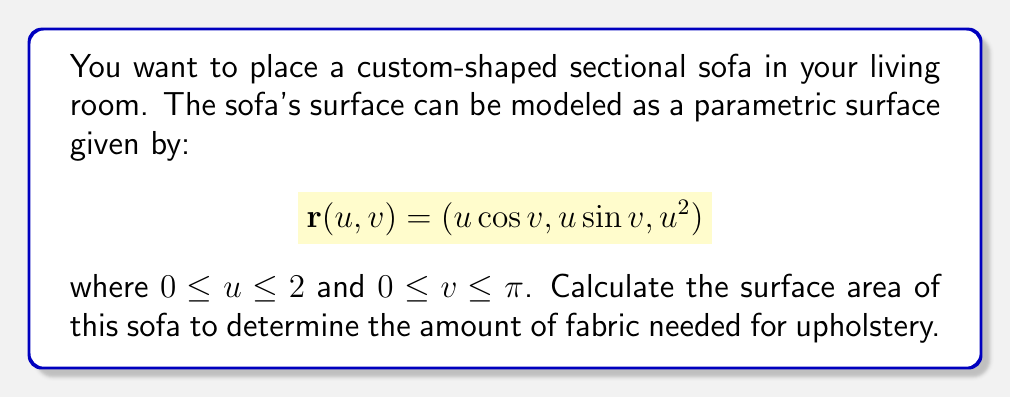Give your solution to this math problem. To calculate the surface area of a parametric surface, we use the surface integral formula:

$$A = \iint_S \sqrt{EG - F^2} \,du\,dv$$

where $E$, $F$, and $G$ are the coefficients of the first fundamental form.

Step 1: Calculate the partial derivatives
$$\frac{\partial \mathbf{r}}{\partial u} = (\cos v, \sin v, 2u)$$
$$\frac{\partial \mathbf{r}}{\partial v} = (-u\sin v, u\cos v, 0)$$

Step 2: Calculate $E$, $F$, and $G$
$$E = \left(\frac{\partial \mathbf{r}}{\partial u}\right)^2 = \cos^2 v + \sin^2 v + 4u^2 = 1 + 4u^2$$
$$F = \frac{\partial \mathbf{r}}{\partial u} \cdot \frac{\partial \mathbf{r}}{\partial v} = -u\sin v \cos v + u\sin v \cos v = 0$$
$$G = \left(\frac{\partial \mathbf{r}}{\partial v}\right)^2 = u^2\sin^2 v + u^2\cos^2 v = u^2$$

Step 3: Calculate $EG - F^2$
$$EG - F^2 = (1 + 4u^2)(u^2) - 0^2 = u^2 + 4u^4$$

Step 4: Set up the surface integral
$$A = \int_0^\pi \int_0^2 \sqrt{u^2 + 4u^4} \,du\,dv$$

Step 5: Evaluate the integral
First, integrate with respect to $u$:
$$\int_0^2 \sqrt{u^2 + 4u^4} \,du = \left[\frac{1}{6}u(1+2u^2)\sqrt{1+4u^2}\right]_0^2 = \frac{1}{6}(2)(1+8)\sqrt{1+16} = \frac{3\sqrt{17}}{2}$$

Now, integrate with respect to $v$:
$$A = \int_0^\pi \frac{3\sqrt{17}}{2} \,dv = \frac{3\sqrt{17}}{2}\pi$$

Therefore, the surface area of the sofa is $\frac{3\sqrt{17}}{2}\pi$ square units.
Answer: $\frac{3\sqrt{17}}{2}\pi$ square units 